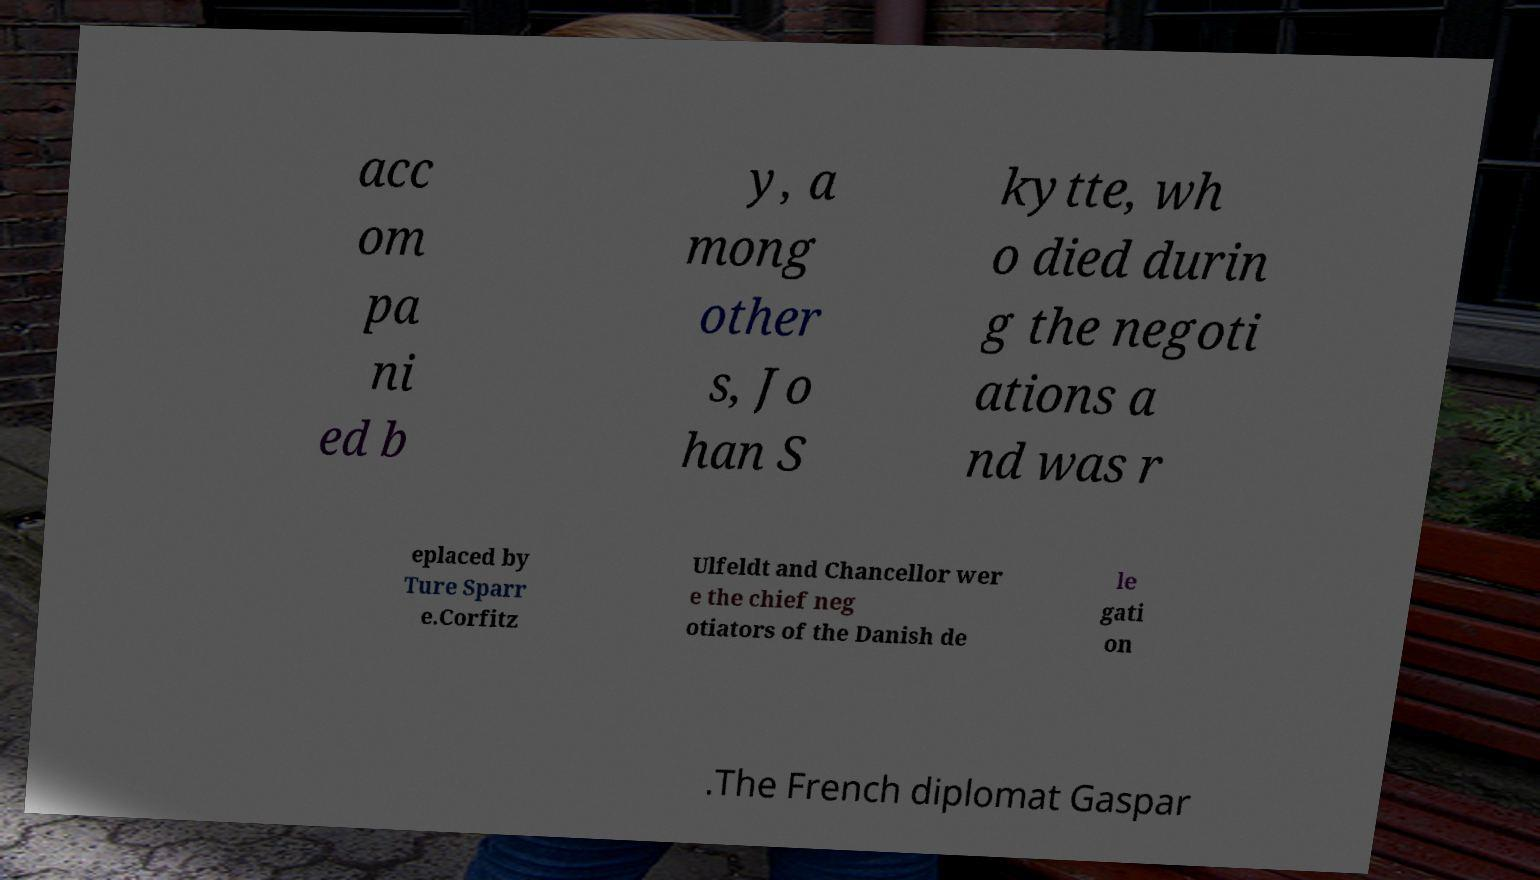I need the written content from this picture converted into text. Can you do that? acc om pa ni ed b y, a mong other s, Jo han S kytte, wh o died durin g the negoti ations a nd was r eplaced by Ture Sparr e.Corfitz Ulfeldt and Chancellor wer e the chief neg otiators of the Danish de le gati on .The French diplomat Gaspar 